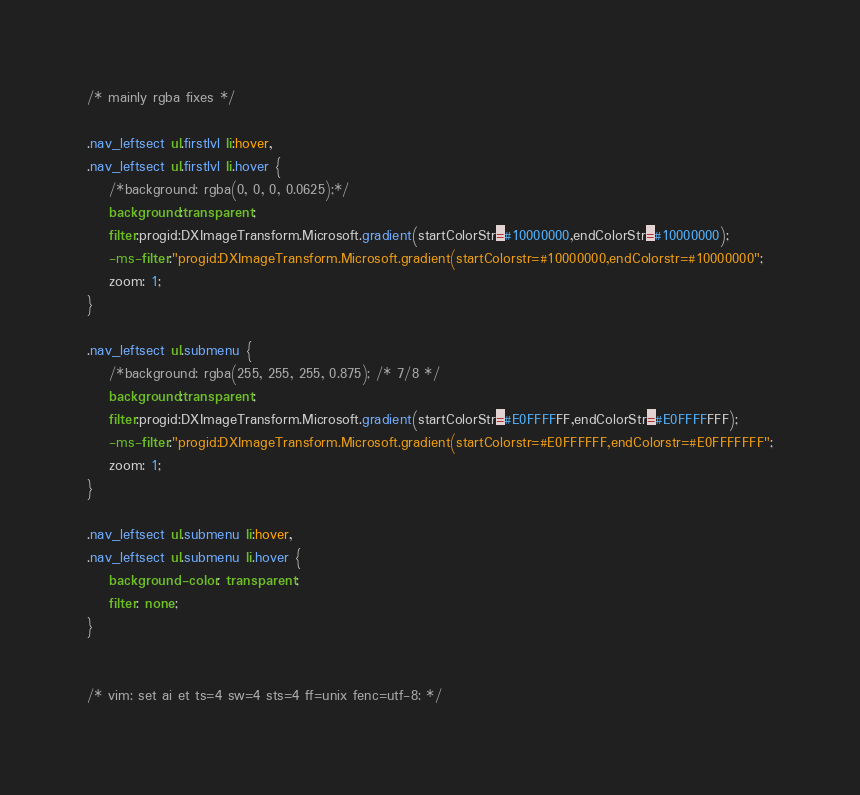Convert code to text. <code><loc_0><loc_0><loc_500><loc_500><_CSS_>/* mainly rgba fixes */

.nav_leftsect ul.firstlvl li:hover,
.nav_leftsect ul.firstlvl li.hover {
    /*background: rgba(0, 0, 0, 0.0625);*/
    background:transparent;
    filter:progid:DXImageTransform.Microsoft.gradient(startColorStr=#10000000,endColorStr=#10000000);
    -ms-filter:"progid:DXImageTransform.Microsoft.gradient(startColorstr=#10000000,endColorstr=#10000000";
    zoom: 1;
}

.nav_leftsect ul.submenu {
    /*background: rgba(255, 255, 255, 0.875); /* 7/8 */
    background:transparent;
    filter:progid:DXImageTransform.Microsoft.gradient(startColorStr=#E0FFFFFF,endColorStr=#E0FFFFFFF);
    -ms-filter:"progid:DXImageTransform.Microsoft.gradient(startColorstr=#E0FFFFFF,endColorstr=#E0FFFFFFF";
    zoom: 1;
}

.nav_leftsect ul.submenu li:hover,
.nav_leftsect ul.submenu li.hover {
    background-color: transparent;
    filter: none;
}


/* vim: set ai et ts=4 sw=4 sts=4 ff=unix fenc=utf-8: */
</code> 